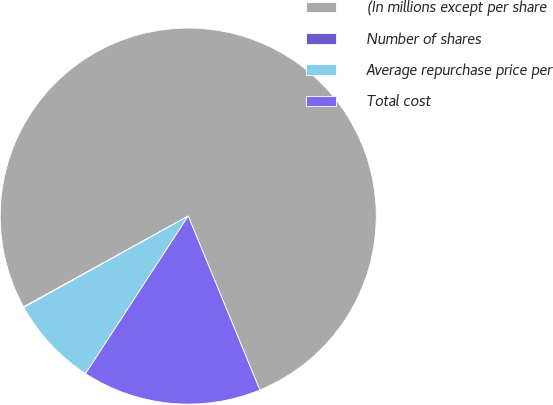Convert chart. <chart><loc_0><loc_0><loc_500><loc_500><pie_chart><fcel>(In millions except per share<fcel>Number of shares<fcel>Average repurchase price per<fcel>Total cost<nl><fcel>76.8%<fcel>0.06%<fcel>7.73%<fcel>15.41%<nl></chart> 